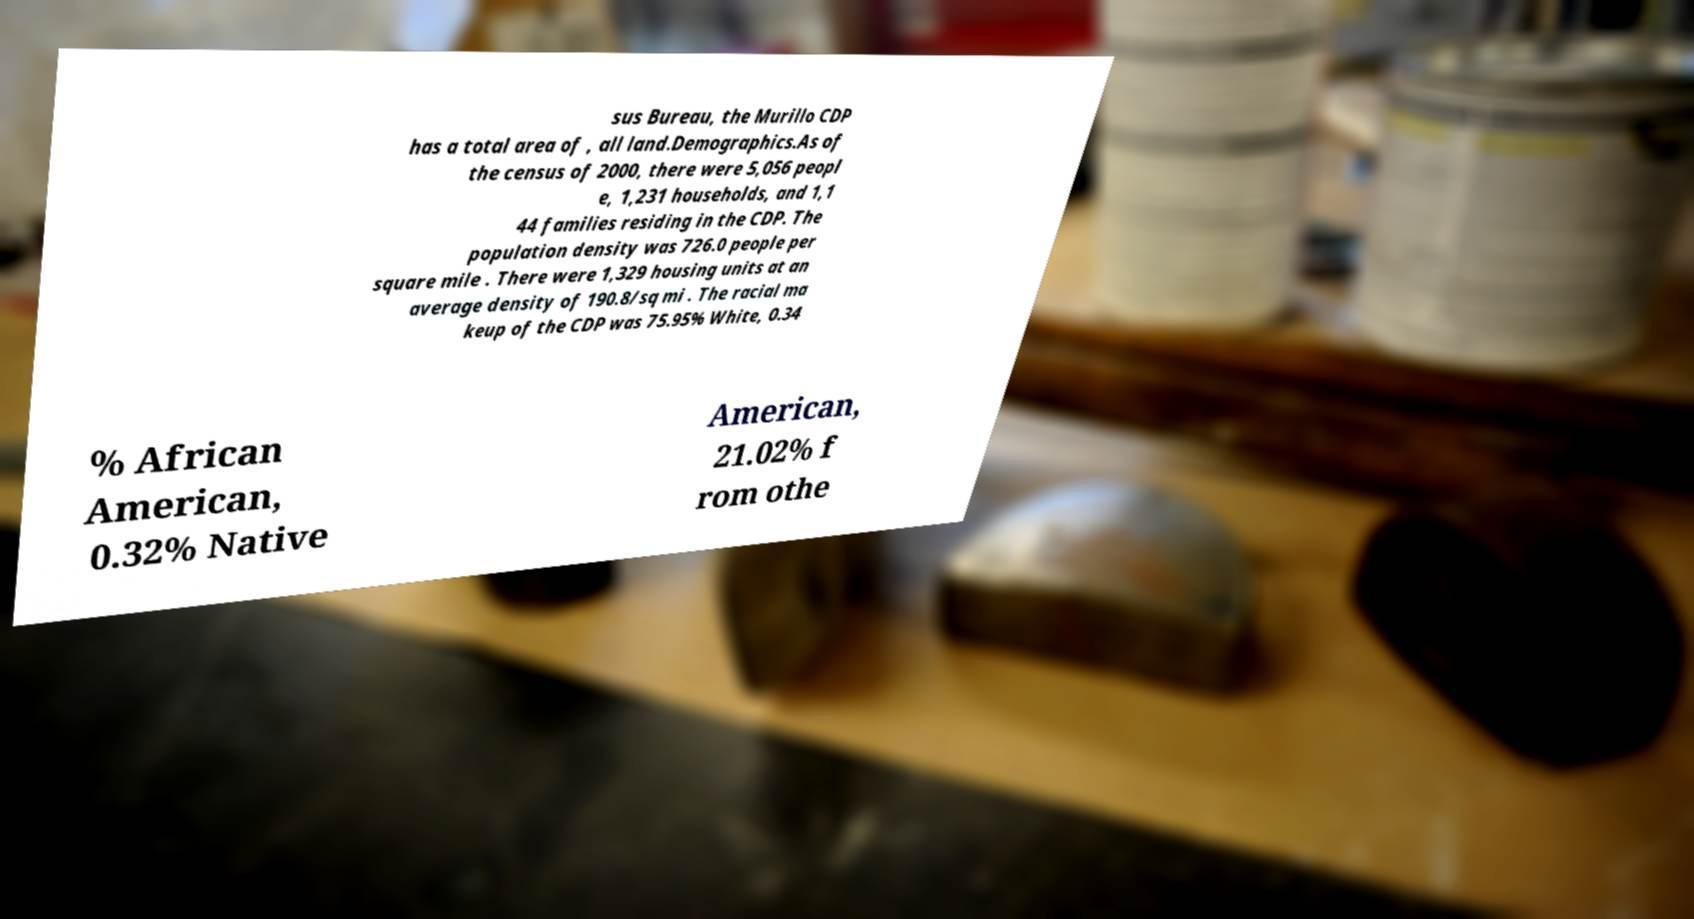Could you extract and type out the text from this image? sus Bureau, the Murillo CDP has a total area of , all land.Demographics.As of the census of 2000, there were 5,056 peopl e, 1,231 households, and 1,1 44 families residing in the CDP. The population density was 726.0 people per square mile . There were 1,329 housing units at an average density of 190.8/sq mi . The racial ma keup of the CDP was 75.95% White, 0.34 % African American, 0.32% Native American, 21.02% f rom othe 